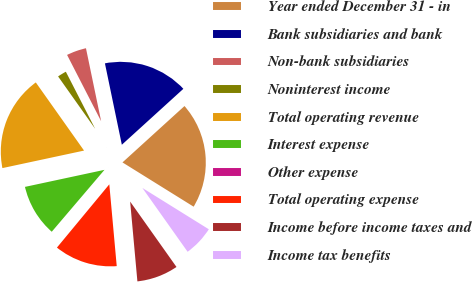<chart> <loc_0><loc_0><loc_500><loc_500><pie_chart><fcel>Year ended December 31 - in<fcel>Bank subsidiaries and bank<fcel>Non-bank subsidiaries<fcel>Noninterest income<fcel>Total operating revenue<fcel>Interest expense<fcel>Other expense<fcel>Total operating expense<fcel>Income before income taxes and<fcel>Income tax benefits<nl><fcel>20.6%<fcel>16.52%<fcel>4.29%<fcel>2.25%<fcel>18.56%<fcel>10.41%<fcel>0.22%<fcel>12.45%<fcel>8.37%<fcel>6.33%<nl></chart> 